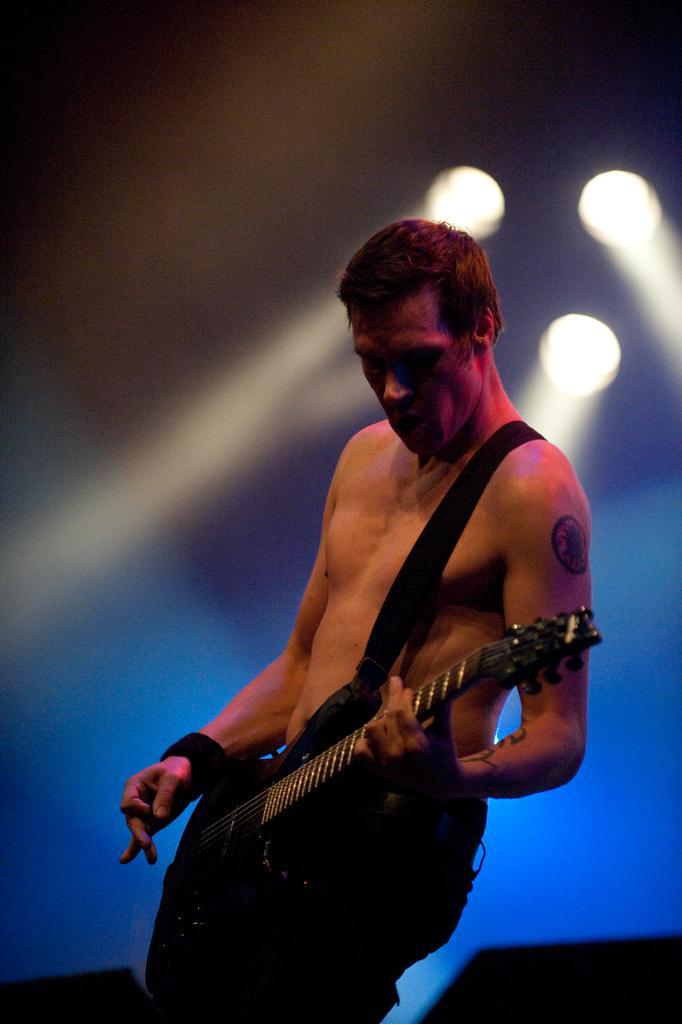Could you give a brief overview of what you see in this image? We can see lights on the background. We can see a man standing and playing guitar. He wore wrist band to his hand. 